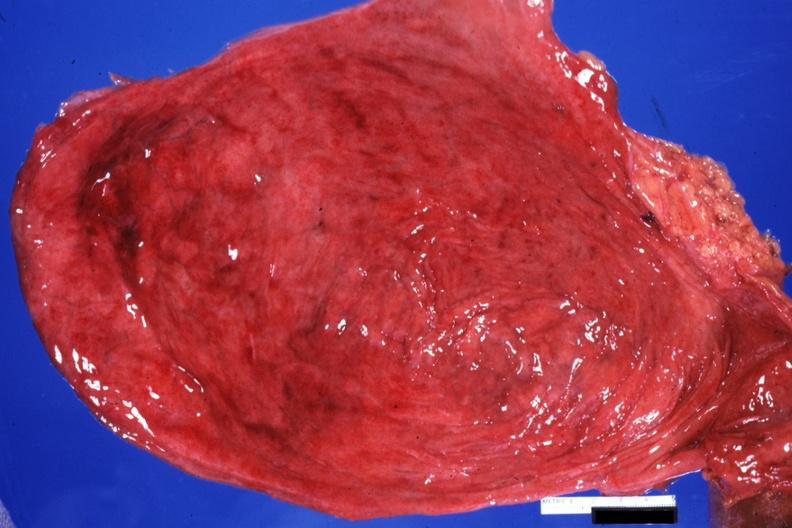s hypertrophy and hemorrhagic cystitis present?
Answer the question using a single word or phrase. Yes 